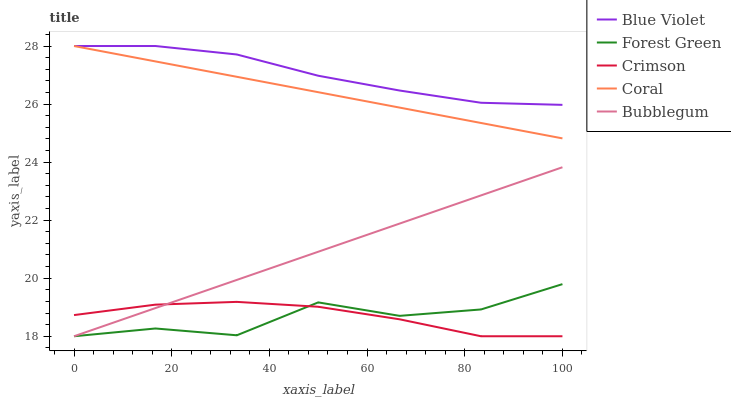Does Forest Green have the minimum area under the curve?
Answer yes or no. Yes. Does Blue Violet have the maximum area under the curve?
Answer yes or no. Yes. Does Bubblegum have the minimum area under the curve?
Answer yes or no. No. Does Bubblegum have the maximum area under the curve?
Answer yes or no. No. Is Coral the smoothest?
Answer yes or no. Yes. Is Forest Green the roughest?
Answer yes or no. Yes. Is Bubblegum the smoothest?
Answer yes or no. No. Is Bubblegum the roughest?
Answer yes or no. No. Does Crimson have the lowest value?
Answer yes or no. Yes. Does Coral have the lowest value?
Answer yes or no. No. Does Blue Violet have the highest value?
Answer yes or no. Yes. Does Forest Green have the highest value?
Answer yes or no. No. Is Crimson less than Coral?
Answer yes or no. Yes. Is Coral greater than Bubblegum?
Answer yes or no. Yes. Does Forest Green intersect Crimson?
Answer yes or no. Yes. Is Forest Green less than Crimson?
Answer yes or no. No. Is Forest Green greater than Crimson?
Answer yes or no. No. Does Crimson intersect Coral?
Answer yes or no. No. 